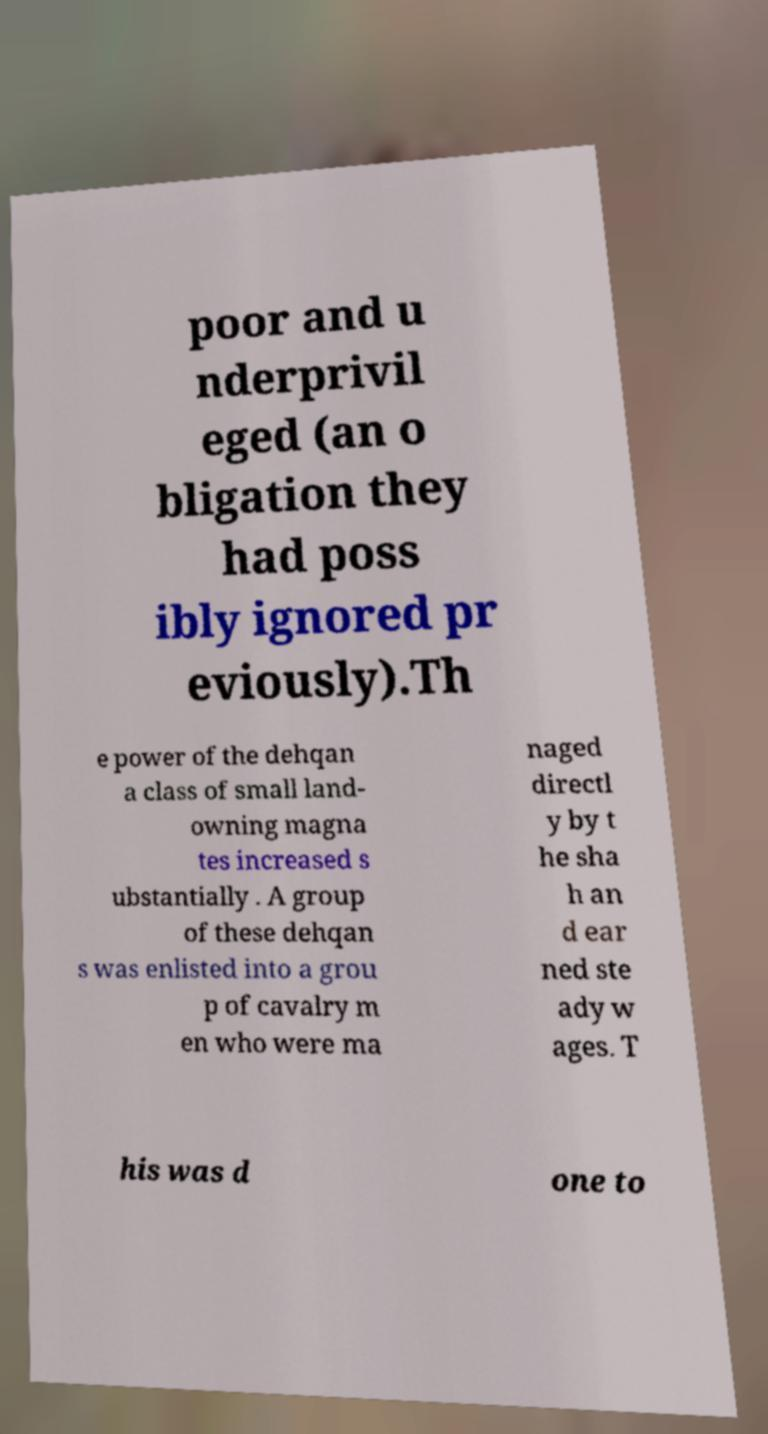There's text embedded in this image that I need extracted. Can you transcribe it verbatim? poor and u nderprivil eged (an o bligation they had poss ibly ignored pr eviously).Th e power of the dehqan a class of small land- owning magna tes increased s ubstantially . A group of these dehqan s was enlisted into a grou p of cavalry m en who were ma naged directl y by t he sha h an d ear ned ste ady w ages. T his was d one to 